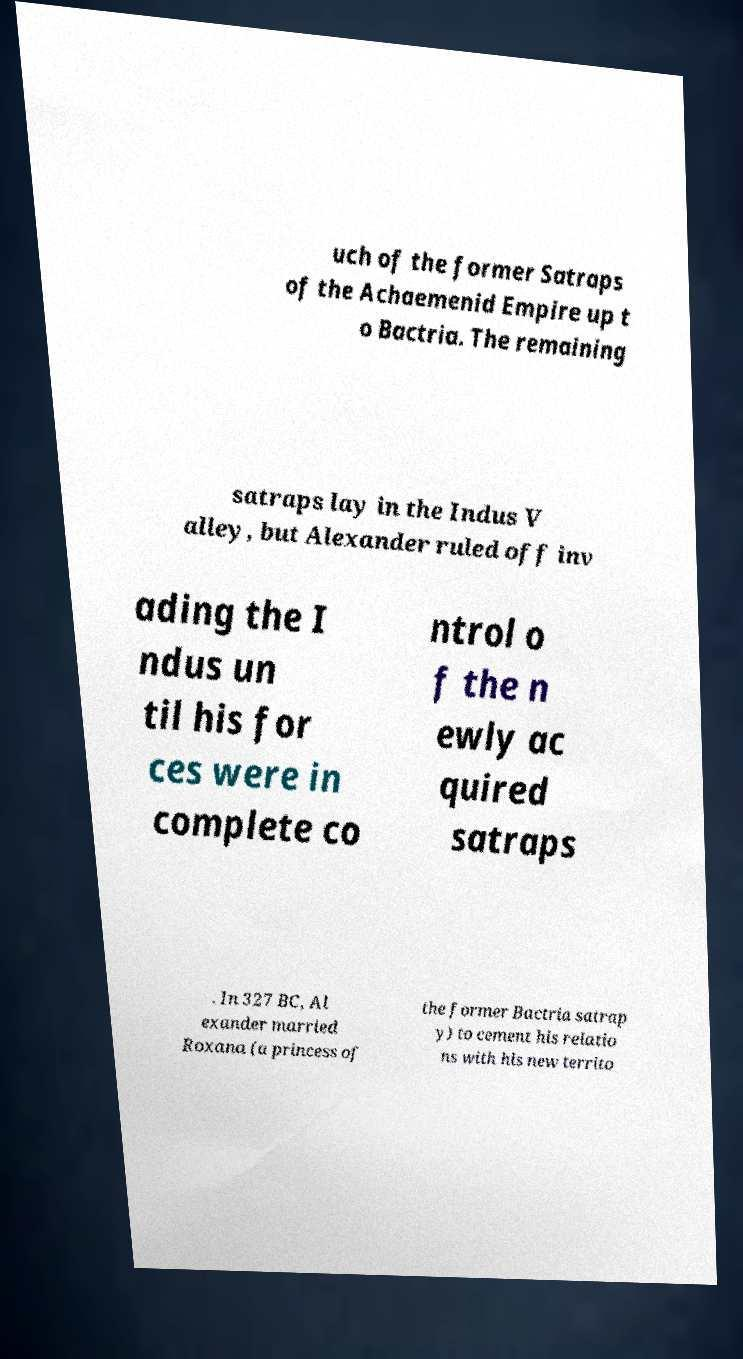Can you accurately transcribe the text from the provided image for me? uch of the former Satraps of the Achaemenid Empire up t o Bactria. The remaining satraps lay in the Indus V alley, but Alexander ruled off inv ading the I ndus un til his for ces were in complete co ntrol o f the n ewly ac quired satraps . In 327 BC, Al exander married Roxana (a princess of the former Bactria satrap y) to cement his relatio ns with his new territo 